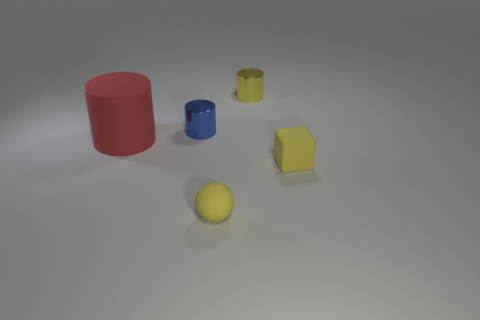Add 3 large green shiny objects. How many objects exist? 8 Subtract all cylinders. How many objects are left? 2 Add 4 small objects. How many small objects exist? 8 Subtract 1 red cylinders. How many objects are left? 4 Subtract all large red rubber cylinders. Subtract all blue metal objects. How many objects are left? 3 Add 5 tiny yellow shiny objects. How many tiny yellow shiny objects are left? 6 